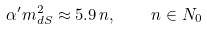Convert formula to latex. <formula><loc_0><loc_0><loc_500><loc_500>\alpha ^ { \prime } m _ { d S } ^ { 2 } \approx 5 . 9 \, n , \quad n \in N _ { 0 }</formula> 